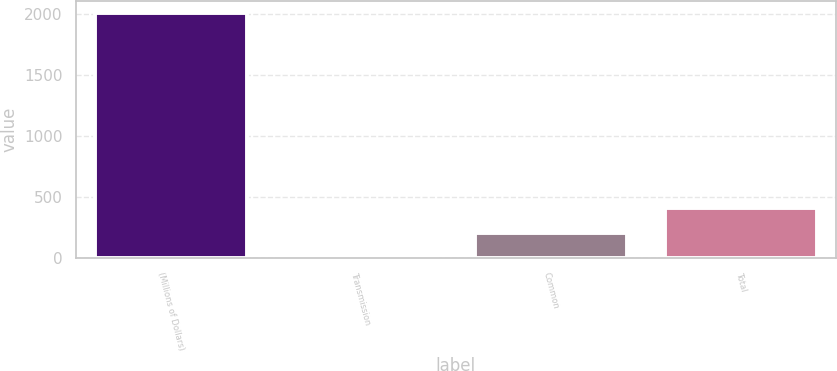<chart> <loc_0><loc_0><loc_500><loc_500><bar_chart><fcel>(Millions of Dollars)<fcel>Transmission<fcel>Common<fcel>Total<nl><fcel>2006<fcel>7<fcel>206.9<fcel>406.8<nl></chart> 